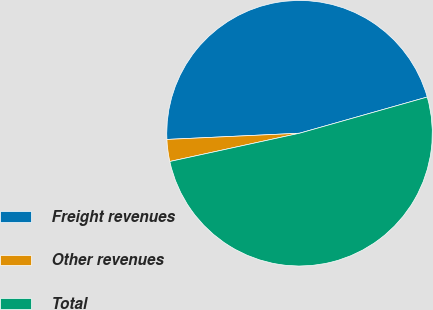<chart> <loc_0><loc_0><loc_500><loc_500><pie_chart><fcel>Freight revenues<fcel>Other revenues<fcel>Total<nl><fcel>46.35%<fcel>2.67%<fcel>50.98%<nl></chart> 